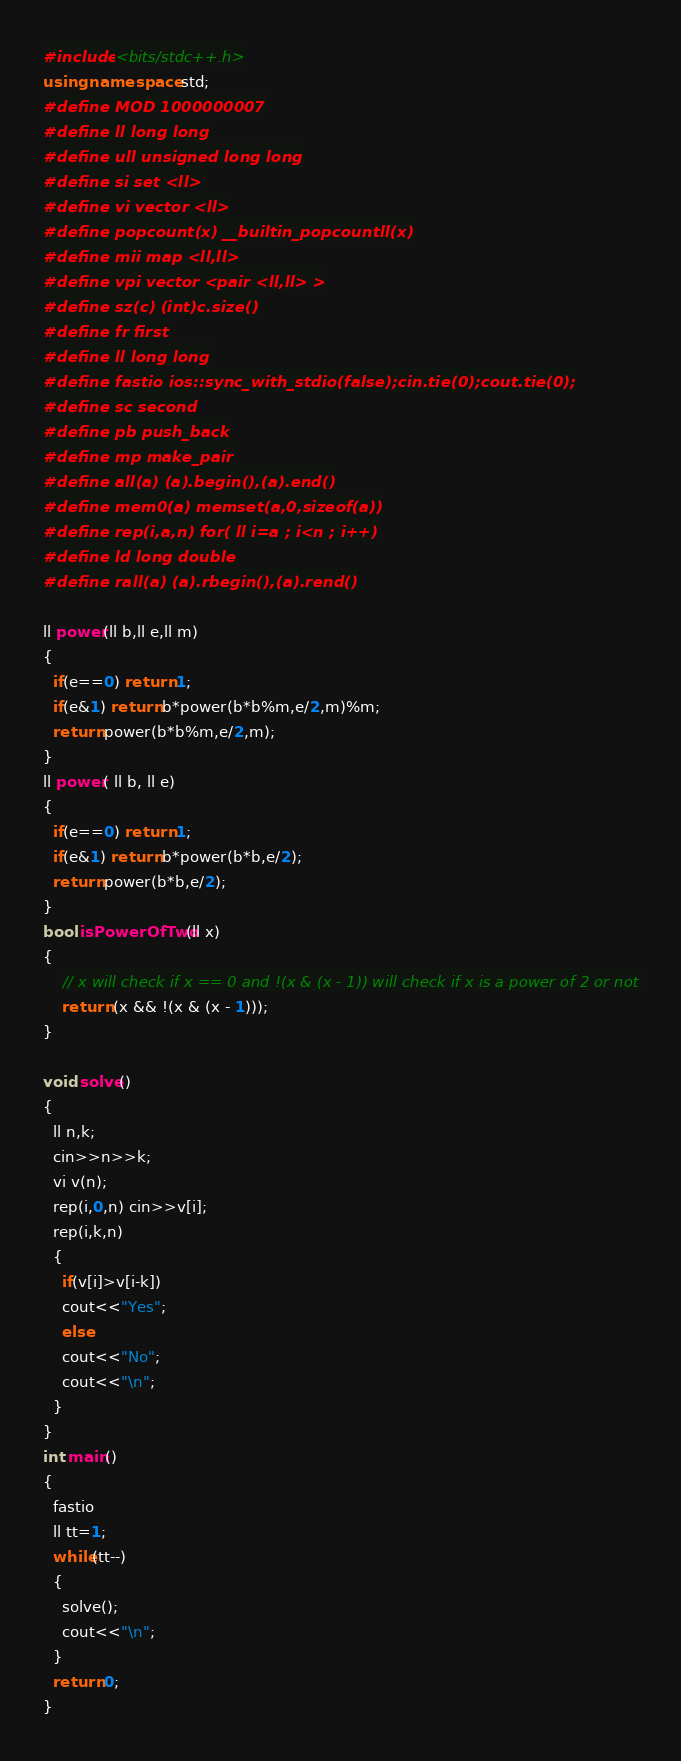<code> <loc_0><loc_0><loc_500><loc_500><_C++_>#include <bits/stdc++.h>
using namespace std;
#define MOD 1000000007
#define ll long long
#define ull unsigned long long
#define si set <ll>
#define vi vector <ll>
#define popcount(x) __builtin_popcountll(x)
#define mii map <ll,ll>
#define vpi vector <pair <ll,ll> >
#define sz(c) (int)c.size()
#define fr first
#define ll long long
#define fastio ios::sync_with_stdio(false);cin.tie(0);cout.tie(0);
#define sc second
#define pb push_back
#define mp make_pair
#define all(a) (a).begin(),(a).end()
#define mem0(a) memset(a,0,sizeof(a))
#define rep(i,a,n) for( ll i=a ; i<n ; i++)
#define ld long double
#define rall(a) (a).rbegin(),(a).rend()

ll power(ll b,ll e,ll m)
{
  if(e==0) return 1;
  if(e&1) return b*power(b*b%m,e/2,m)%m;
  return power(b*b%m,e/2,m);
}
ll power( ll b, ll e)
{
  if(e==0) return 1;
  if(e&1) return b*power(b*b,e/2);
  return power(b*b,e/2);
}  
bool isPowerOfTwo(ll x)
{
    // x will check if x == 0 and !(x & (x - 1)) will check if x is a power of 2 or not
    return (x && !(x & (x - 1)));
} 

void solve()
{
  ll n,k;
  cin>>n>>k;
  vi v(n);
  rep(i,0,n) cin>>v[i];
  rep(i,k,n)
  {
    if(v[i]>v[i-k])
    cout<<"Yes";
    else
    cout<<"No";
    cout<<"\n";
  }
}
int main()       
{
  fastio
  ll tt=1;
  while(tt--)
  {
    solve();
    cout<<"\n";
  }
  return 0;
}</code> 